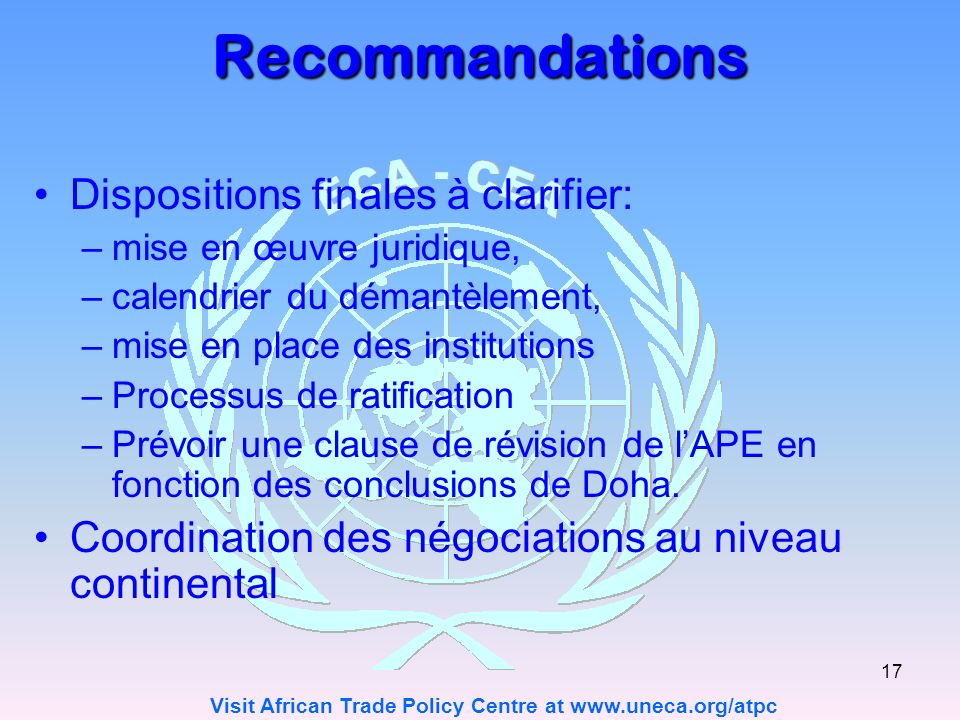What does coordination of negotiations at the continental level imply, and why is it significant? Coordination of negotiations at the continental level implies a harmonized approach to trade whereby countries across the continent engage in negotiations as a collective bloc rather than as individual entities. This is significant because it could lead to more uniformly beneficial outcomes that maximize economic benefits for all participating nations. By negotiating as a bloc, smaller or less economically powerful countries can have a stronger voice and greater leverage. This kind of coordination can also streamline the negotiation process, leading to more cohesive policies and trade agreements that are easier to implement and enforce across multiple countries. 